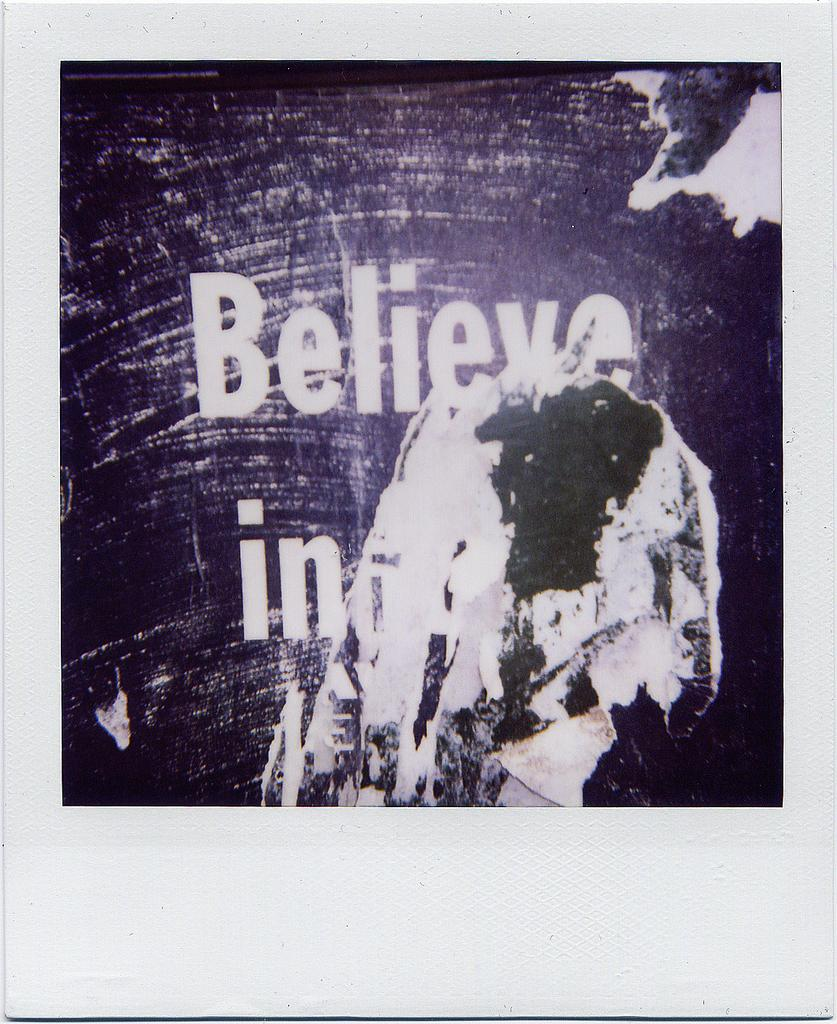What is present on the white surface in the image? There is a poster on the white surface. What can be seen on the poster? The poster has writing on it. What type of apparel is being worn by the tooth in the image? There is no tooth or apparel present in the image; it only features a poster on a white surface with writing. 